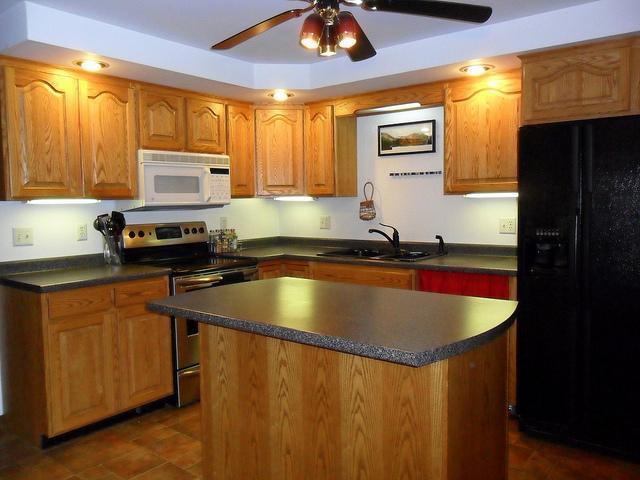How many fan blades are shown?
Give a very brief answer. 3. 